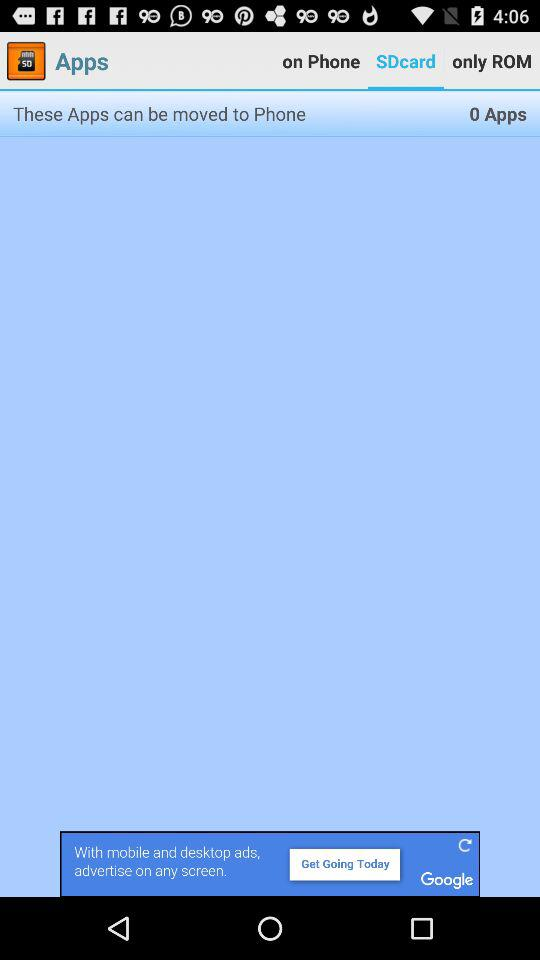Which tab is selected? The selected tab is SDcard. 